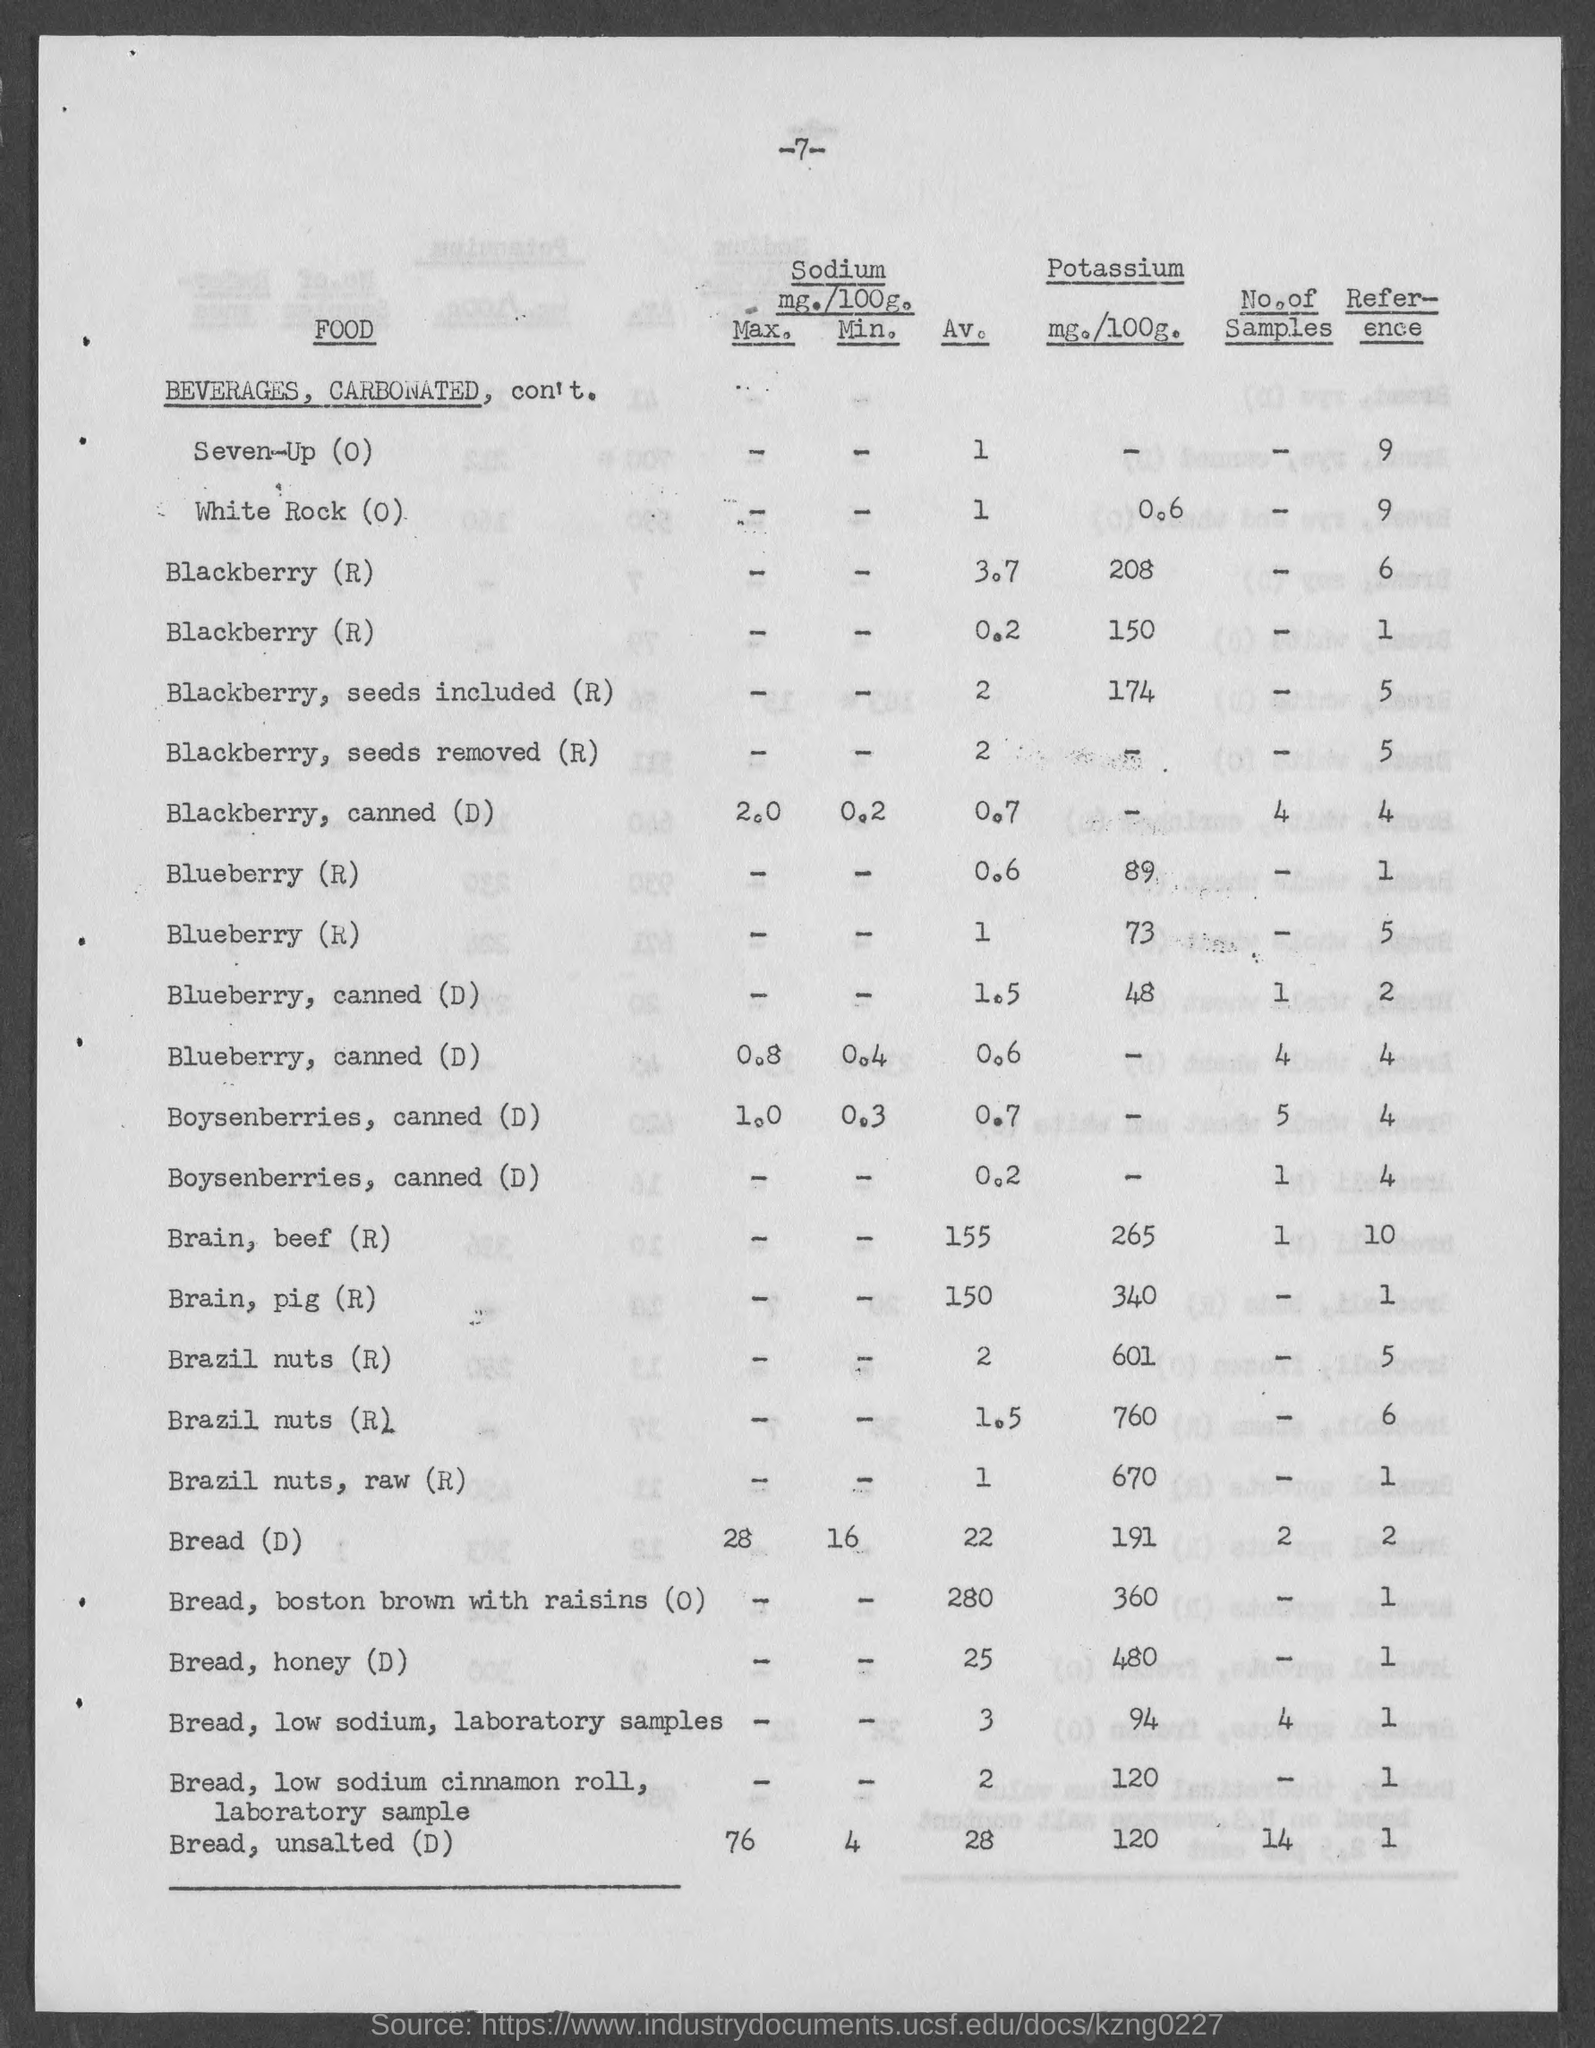What is the number at top of the page ?
Ensure brevity in your answer.  -7-. What is the amount of potassium mg./100g. for white rock ?
Make the answer very short. 0.6. What is the amount of potassium mg./100g. for blackberry, seeds included ?
Your answer should be compact. 174. What is the amount of potassium mg./100g. of brain, beef?
Make the answer very short. 265. What is the amount of potassium mg./100g. for brain,pig?
Your response must be concise. 340. What is the amount of potassium mg./100g. for brazil nuts, raw?
Give a very brief answer. 670. What is the amount of potassium mg./100g. of bread ?
Provide a short and direct response. 191. What is the amount of potassium mg./100g. for bread, boston brown with raisins ?
Your answer should be compact. 360. What is the amount of potassium mg./100g. for bread, honey ?
Give a very brief answer. 480. What is the amount of potassium mg./100g. for bread, unsalted??
Your answer should be compact. 120. 